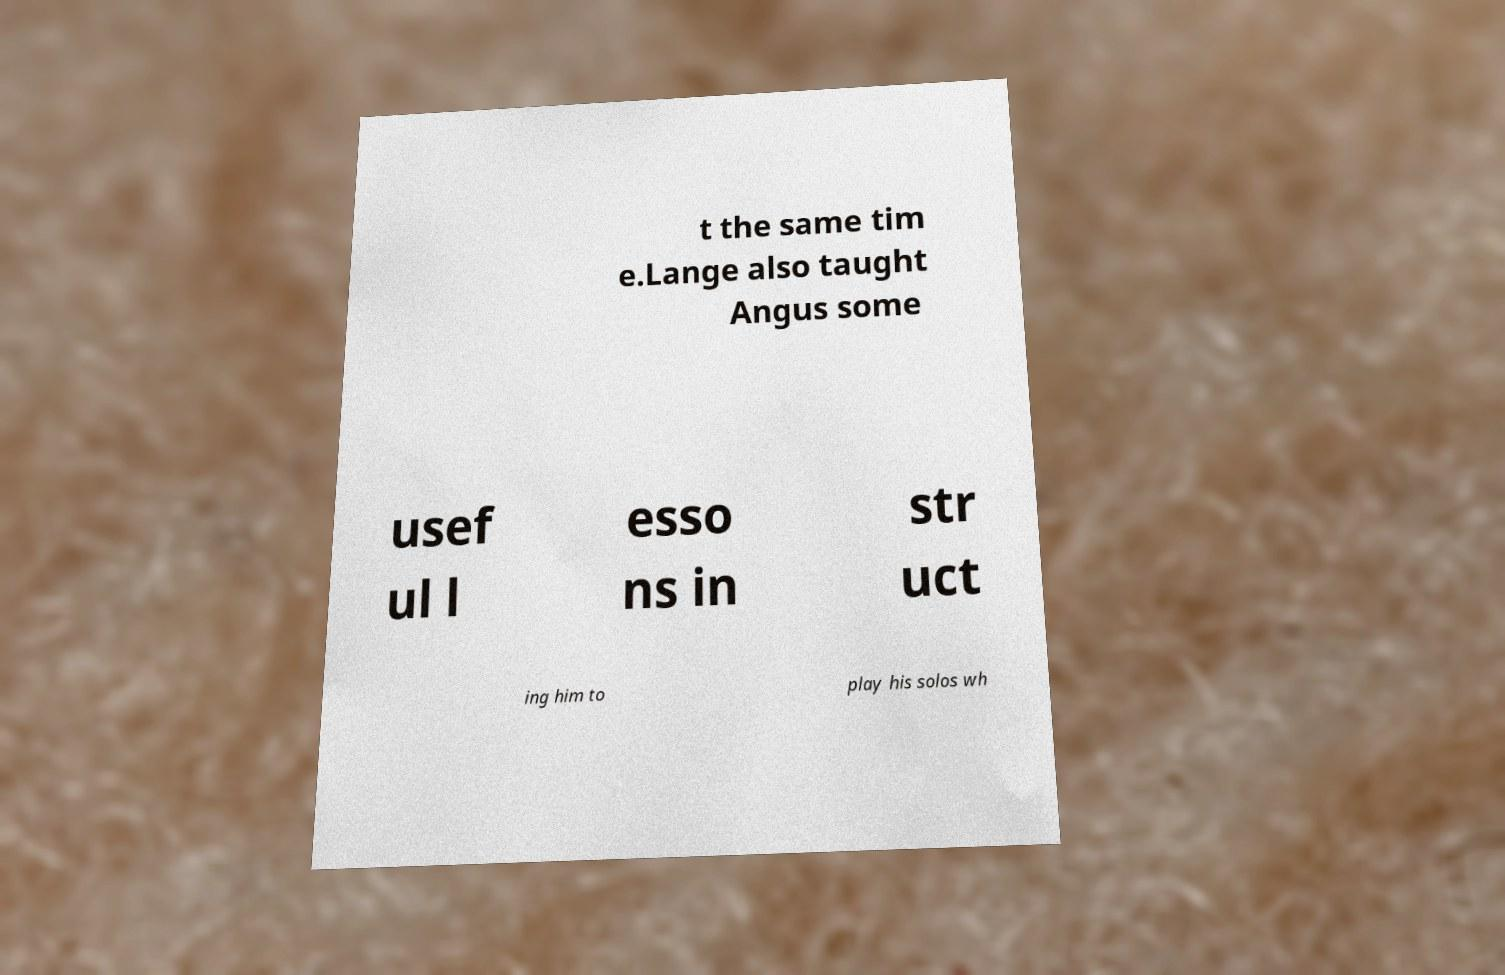I need the written content from this picture converted into text. Can you do that? t the same tim e.Lange also taught Angus some usef ul l esso ns in str uct ing him to play his solos wh 